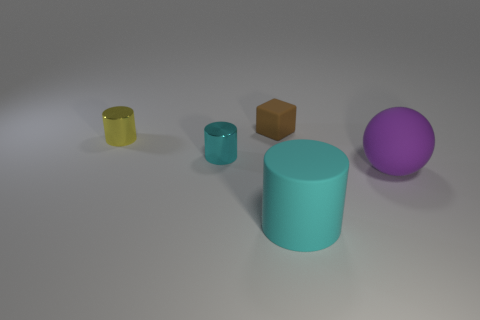How many cyan matte cylinders are there?
Give a very brief answer. 1. How many other metal cylinders are the same color as the large cylinder?
Your answer should be very brief. 1. There is a small metallic thing on the left side of the tiny cyan metal cylinder; is its shape the same as the cyan thing that is on the right side of the cyan shiny object?
Provide a succinct answer. Yes. There is a cylinder that is in front of the large object behind the rubber thing in front of the purple rubber thing; what color is it?
Your answer should be compact. Cyan. What is the color of the large matte thing that is on the left side of the large rubber sphere?
Your response must be concise. Cyan. What is the color of the other shiny thing that is the same size as the cyan metal thing?
Your answer should be compact. Yellow. Do the cyan matte cylinder and the rubber ball have the same size?
Your response must be concise. Yes. There is a large cyan cylinder; how many cylinders are on the left side of it?
Your answer should be very brief. 2. What number of things are things on the left side of the brown rubber cube or brown matte objects?
Your response must be concise. 3. Is the number of large cyan cylinders behind the large purple matte thing greater than the number of tiny yellow cylinders that are right of the yellow metallic cylinder?
Give a very brief answer. No. 